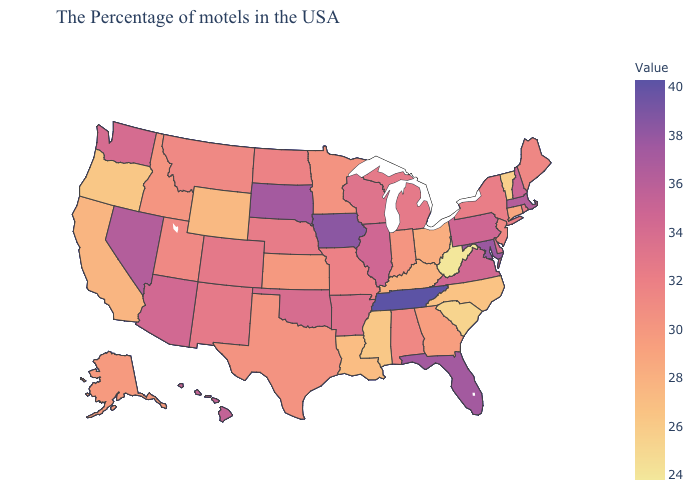Among the states that border Georgia , does Tennessee have the highest value?
Keep it brief. Yes. Among the states that border California , does Nevada have the highest value?
Short answer required. Yes. Among the states that border New Hampshire , which have the lowest value?
Give a very brief answer. Vermont. Does Utah have a higher value than New Hampshire?
Write a very short answer. No. Does the map have missing data?
Concise answer only. No. 